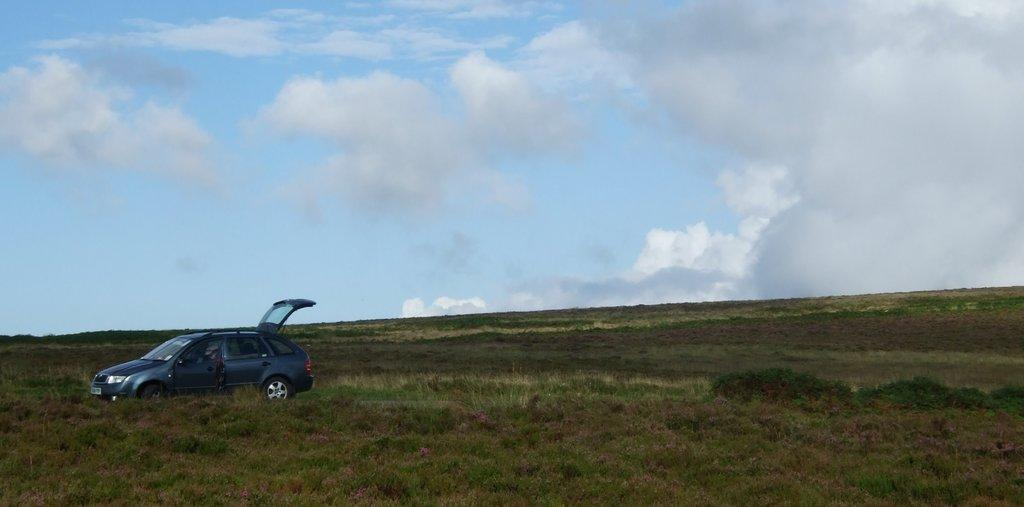What is the main subject of the image? The main subject of the image is a car. Where is the car located in the image? The car is placed on the grass. What can be seen in the background of the image? The sky is visible in the image. How would you describe the sky in the image? The sky appears to be cloudy. How many bulbs are attached to the car in the image? There are no bulbs attached to the car in the image. Can you see any ladybugs on the car in the image? There are no ladybugs visible on the car in the image. 